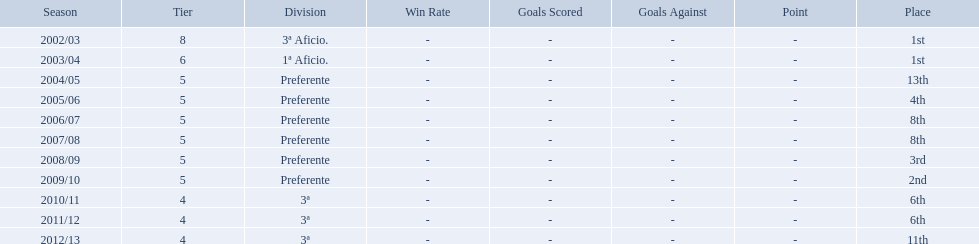What place did the team place in 2010/11? 6th. In what other year did they place 6th? 2011/12. 